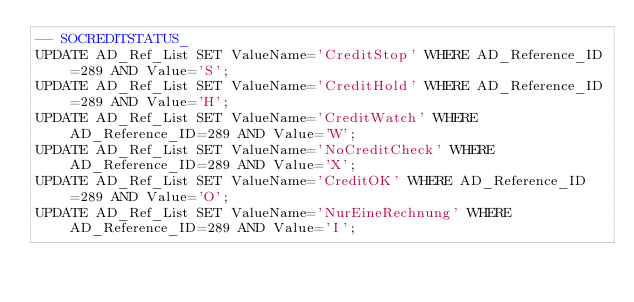<code> <loc_0><loc_0><loc_500><loc_500><_SQL_>-- SOCREDITSTATUS_
UPDATE AD_Ref_List SET ValueName='CreditStop' WHERE AD_Reference_ID=289 AND Value='S';
UPDATE AD_Ref_List SET ValueName='CreditHold' WHERE AD_Reference_ID=289 AND Value='H';
UPDATE AD_Ref_List SET ValueName='CreditWatch' WHERE AD_Reference_ID=289 AND Value='W';
UPDATE AD_Ref_List SET ValueName='NoCreditCheck' WHERE AD_Reference_ID=289 AND Value='X';
UPDATE AD_Ref_List SET ValueName='CreditOK' WHERE AD_Reference_ID=289 AND Value='O';
UPDATE AD_Ref_List SET ValueName='NurEineRechnung' WHERE AD_Reference_ID=289 AND Value='I';


</code> 